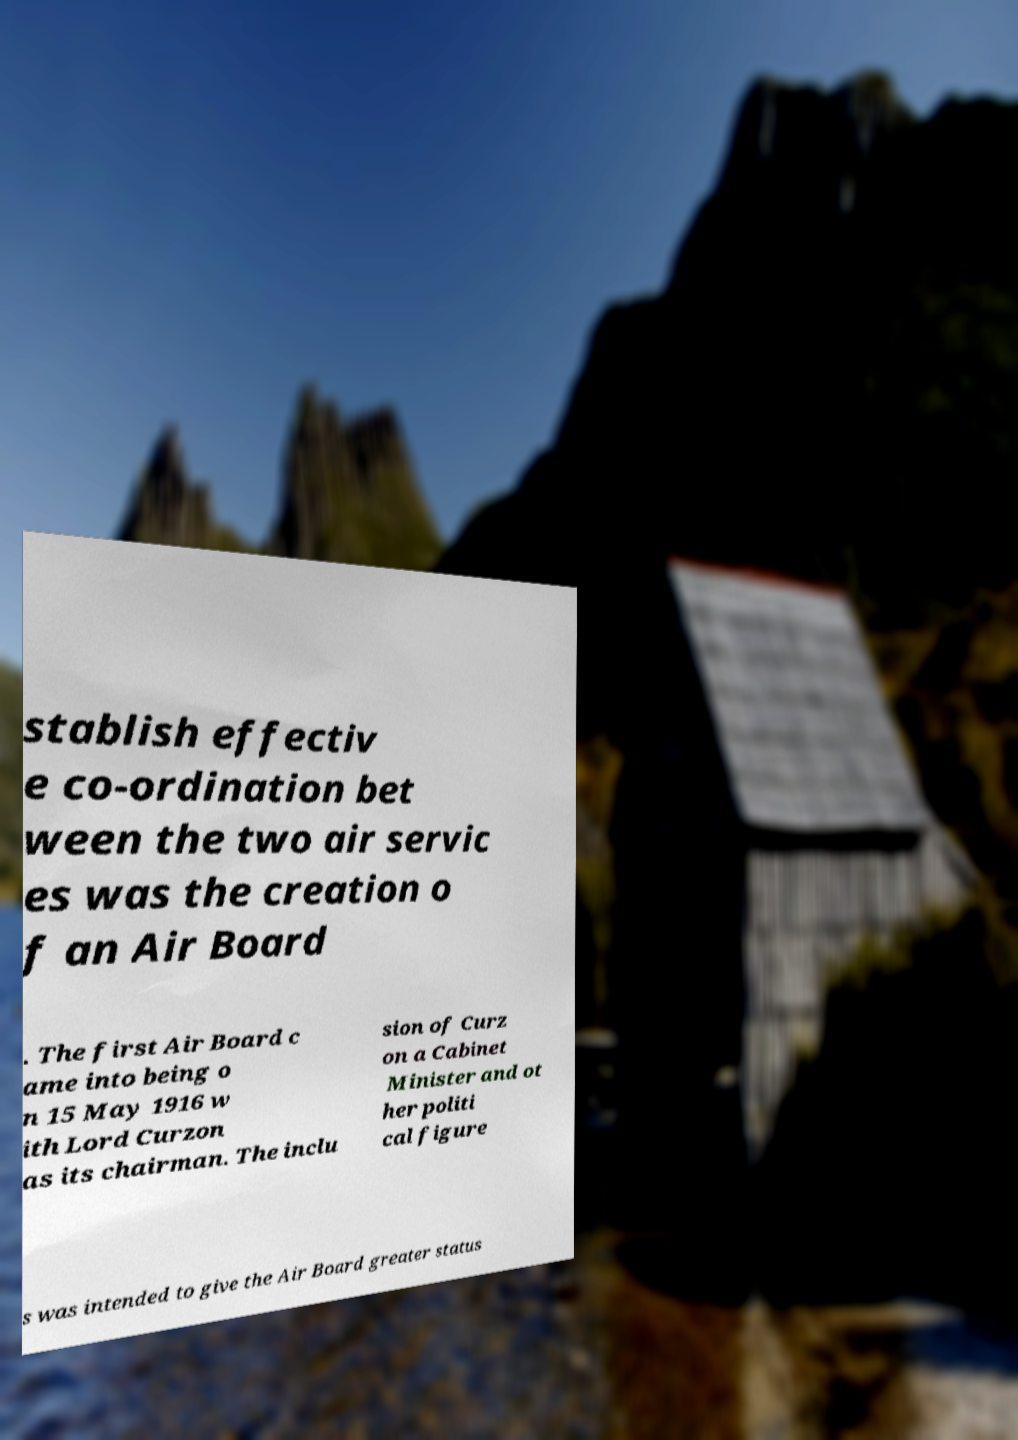Please identify and transcribe the text found in this image. stablish effectiv e co-ordination bet ween the two air servic es was the creation o f an Air Board . The first Air Board c ame into being o n 15 May 1916 w ith Lord Curzon as its chairman. The inclu sion of Curz on a Cabinet Minister and ot her politi cal figure s was intended to give the Air Board greater status 